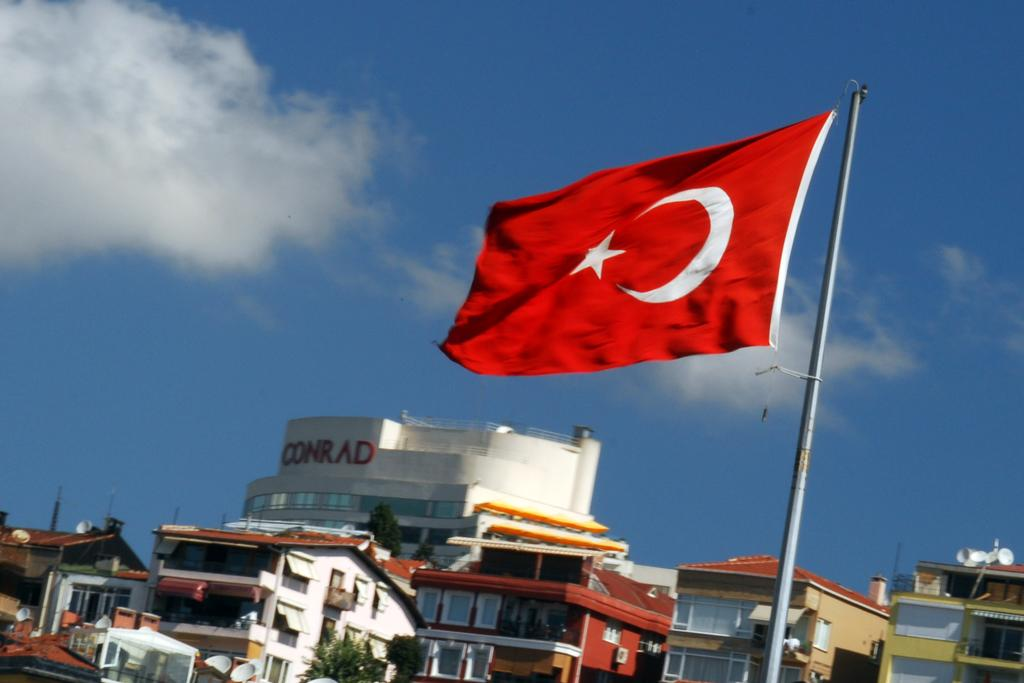What can be seen on the right side of the image? There is a red flag on the right side of the image. What is visible in the background of the image? There are buildings in the background of the image. What is located in front of the buildings? There is a tree in front of the buildings. What is visible at the top of the image? The sky is visible in the image. What can be observed in the sky? Clouds are present in the sky. Can you tell me how many geese are flying in the image? There are no geese present in the image; it features a red flag, buildings, a tree, and clouds in the sky. 